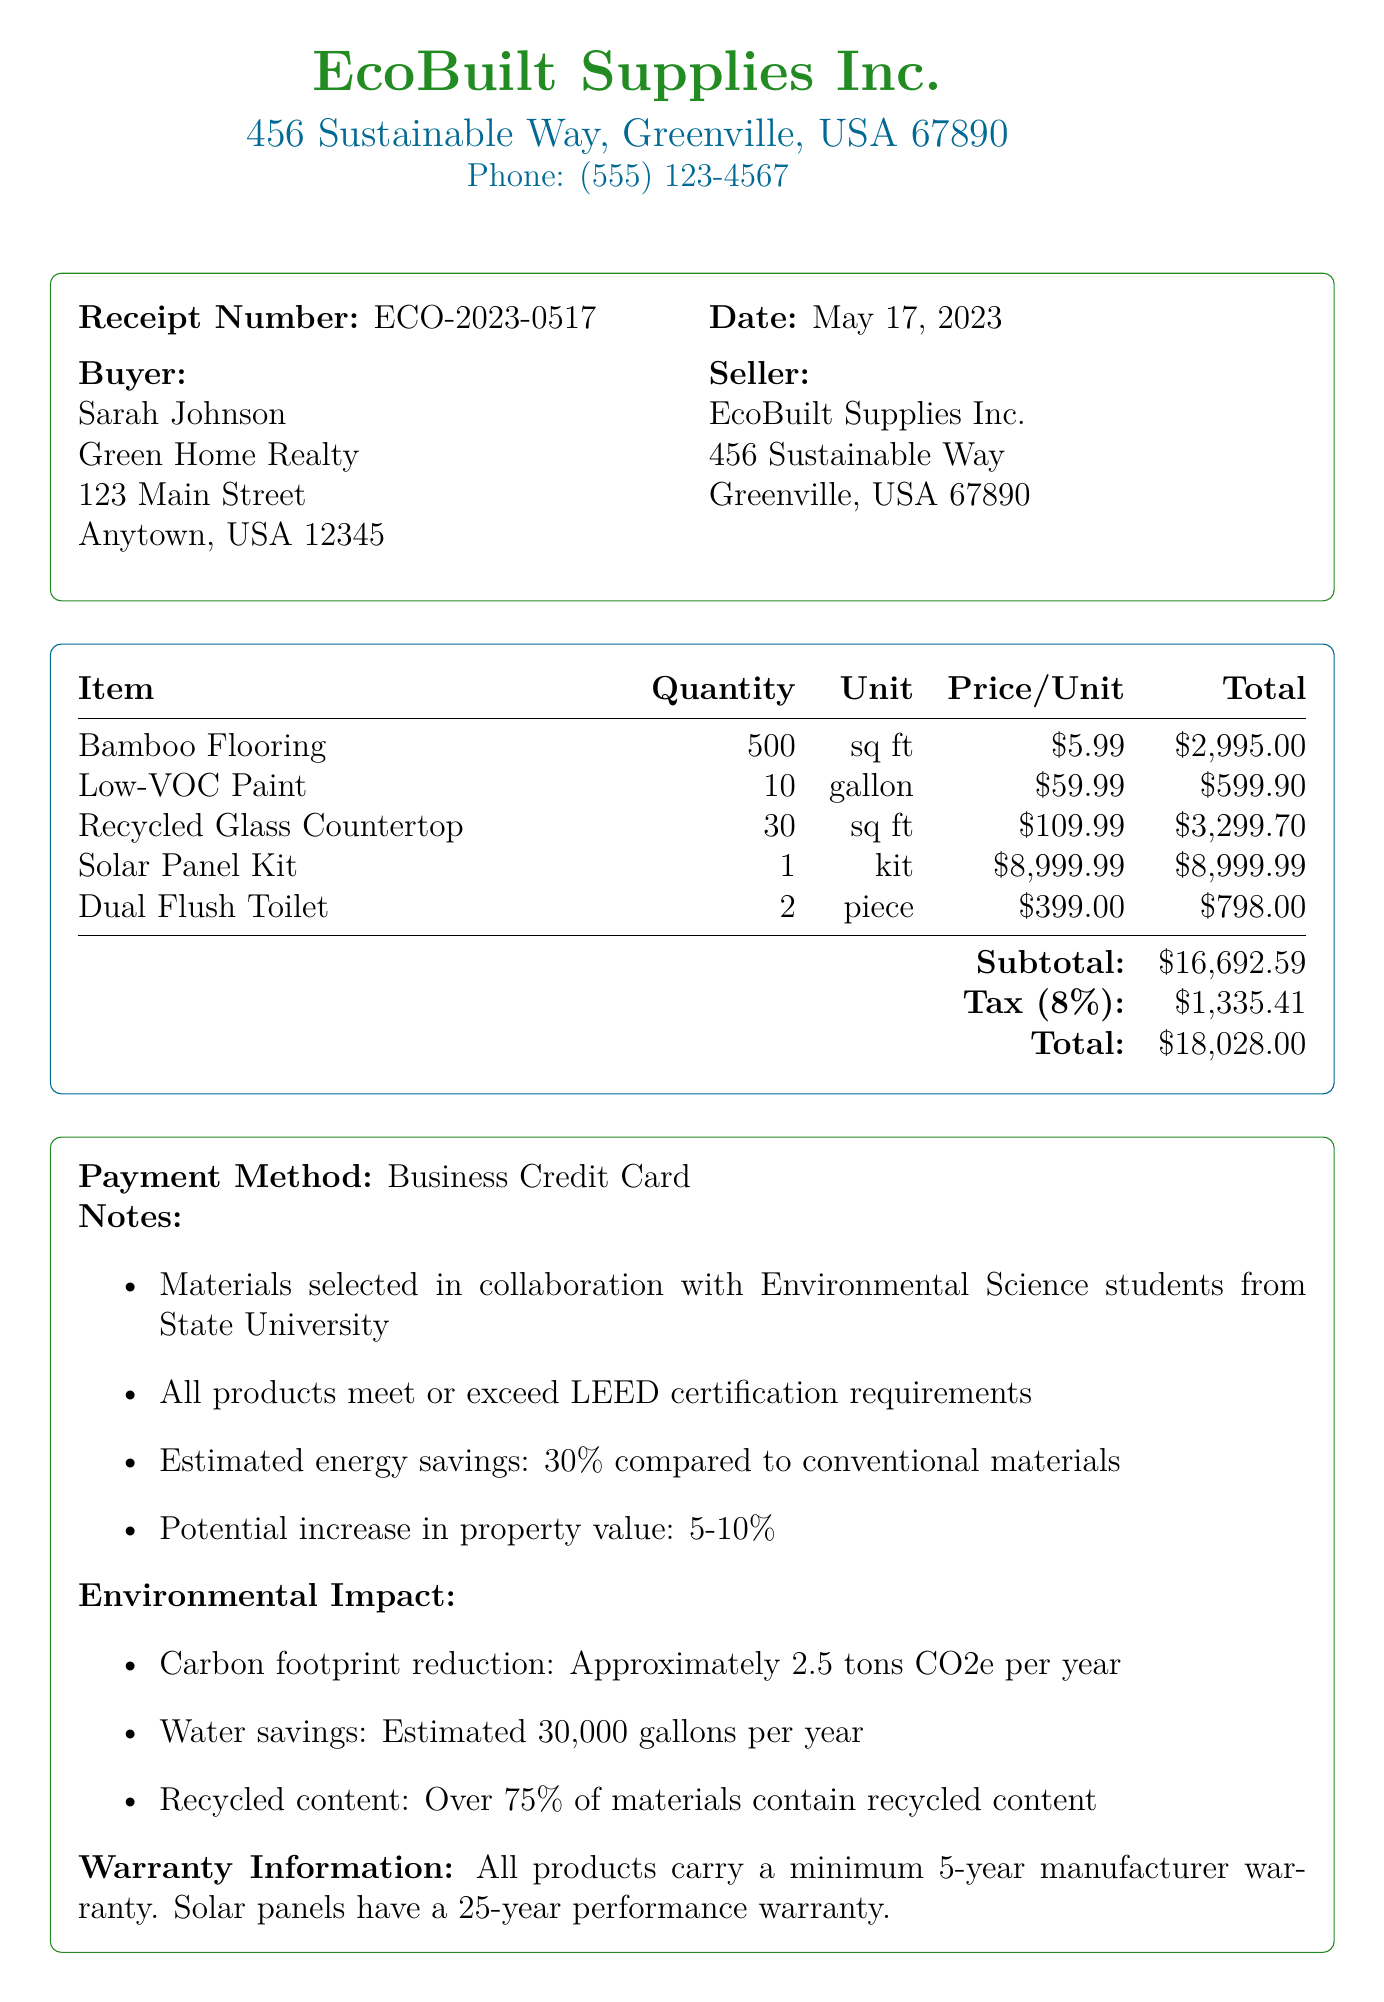What is the receipt number? The receipt number is specified in the document as ECO-2023-0517.
Answer: ECO-2023-0517 Who is the buyer? The buyer's name and company are mentioned in the document as Sarah Johnson from Green Home Realty.
Answer: Sarah Johnson What is the total amount charged? The total amount charged is indicated as the final sum in the document, which includes tax and other charges.
Answer: $18028.00 How many gallons of Low-VOC paint were purchased? The document clearly states the quantity of Low-VOC paint bought, which is shown in the itemized list.
Answer: 10 What is the estimated potential increase in property value? The estimated potential increase in property value is mentioned in the notes section of the document.
Answer: 5-10% What is the environmental impact of the materials in terms of carbon footprint reduction? The carbon footprint reduction is listed in the environmental impact section of the document.
Answer: Approximately 2.5 tons CO2e per year What is the warranty period for the solar panels? The warranty information provided in the document specifies the warranty for solar panels.
Answer: 25-year performance warranty What payment method was used for the transaction? The payment method used is mentioned directly in the document.
Answer: Business Credit Card How many pieces of the Dual Flush Toilet were bought? The document lists the quantity of Dual Flush Toilets purchased in the items section.
Answer: 2 